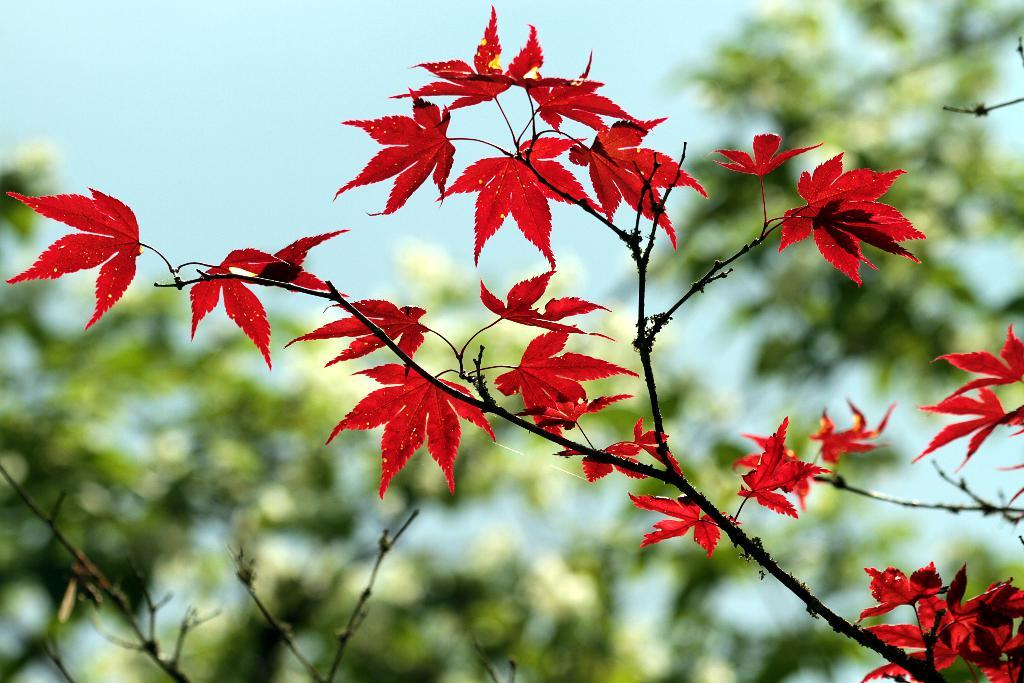What is present in the foreground of the image? There are red color leaves in the foreground of the image. How are the leaves connected to each other? The leaves are attached to a stem. What can be seen in the background of the image? There is a tree and the sky visible in the background of the image. What type of lace can be seen on the leaves in the image? There is no lace present on the leaves in the image. Is there any blood visible on the leaves in the image? There is no blood visible on the leaves in the image. 